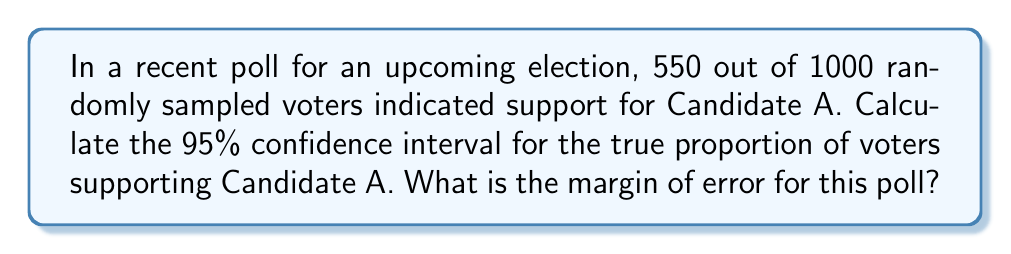Provide a solution to this math problem. Let's approach this step-by-step:

1) First, we need to calculate the sample proportion:
   $\hat{p} = \frac{550}{1000} = 0.55$

2) The formula for the margin of error (ME) at a 95% confidence level is:
   $ME = z^* \sqrt{\frac{\hat{p}(1-\hat{p})}{n}}$

   Where:
   $z^*$ is the critical value (1.96 for 95% confidence)
   $\hat{p}$ is the sample proportion
   $n$ is the sample size

3) Let's calculate the margin of error:
   $ME = 1.96 \sqrt{\frac{0.55(1-0.55)}{1000}}$
   $ME = 1.96 \sqrt{\frac{0.2475}{1000}}$
   $ME = 1.96 \sqrt{0.0002475}$
   $ME = 1.96 * 0.01573$
   $ME = 0.03083$ or about 3.08%

4) The confidence interval is calculated as:
   $\hat{p} \pm ME$

5) Therefore, the 95% confidence interval is:
   $0.55 \pm 0.03083$
   $(0.51917, 0.58083)$

This means we can be 95% confident that the true proportion of voters supporting Candidate A is between 51.92% and 58.08%.
Answer: 95% CI: (0.51917, 0.58083); Margin of Error: 3.08% 